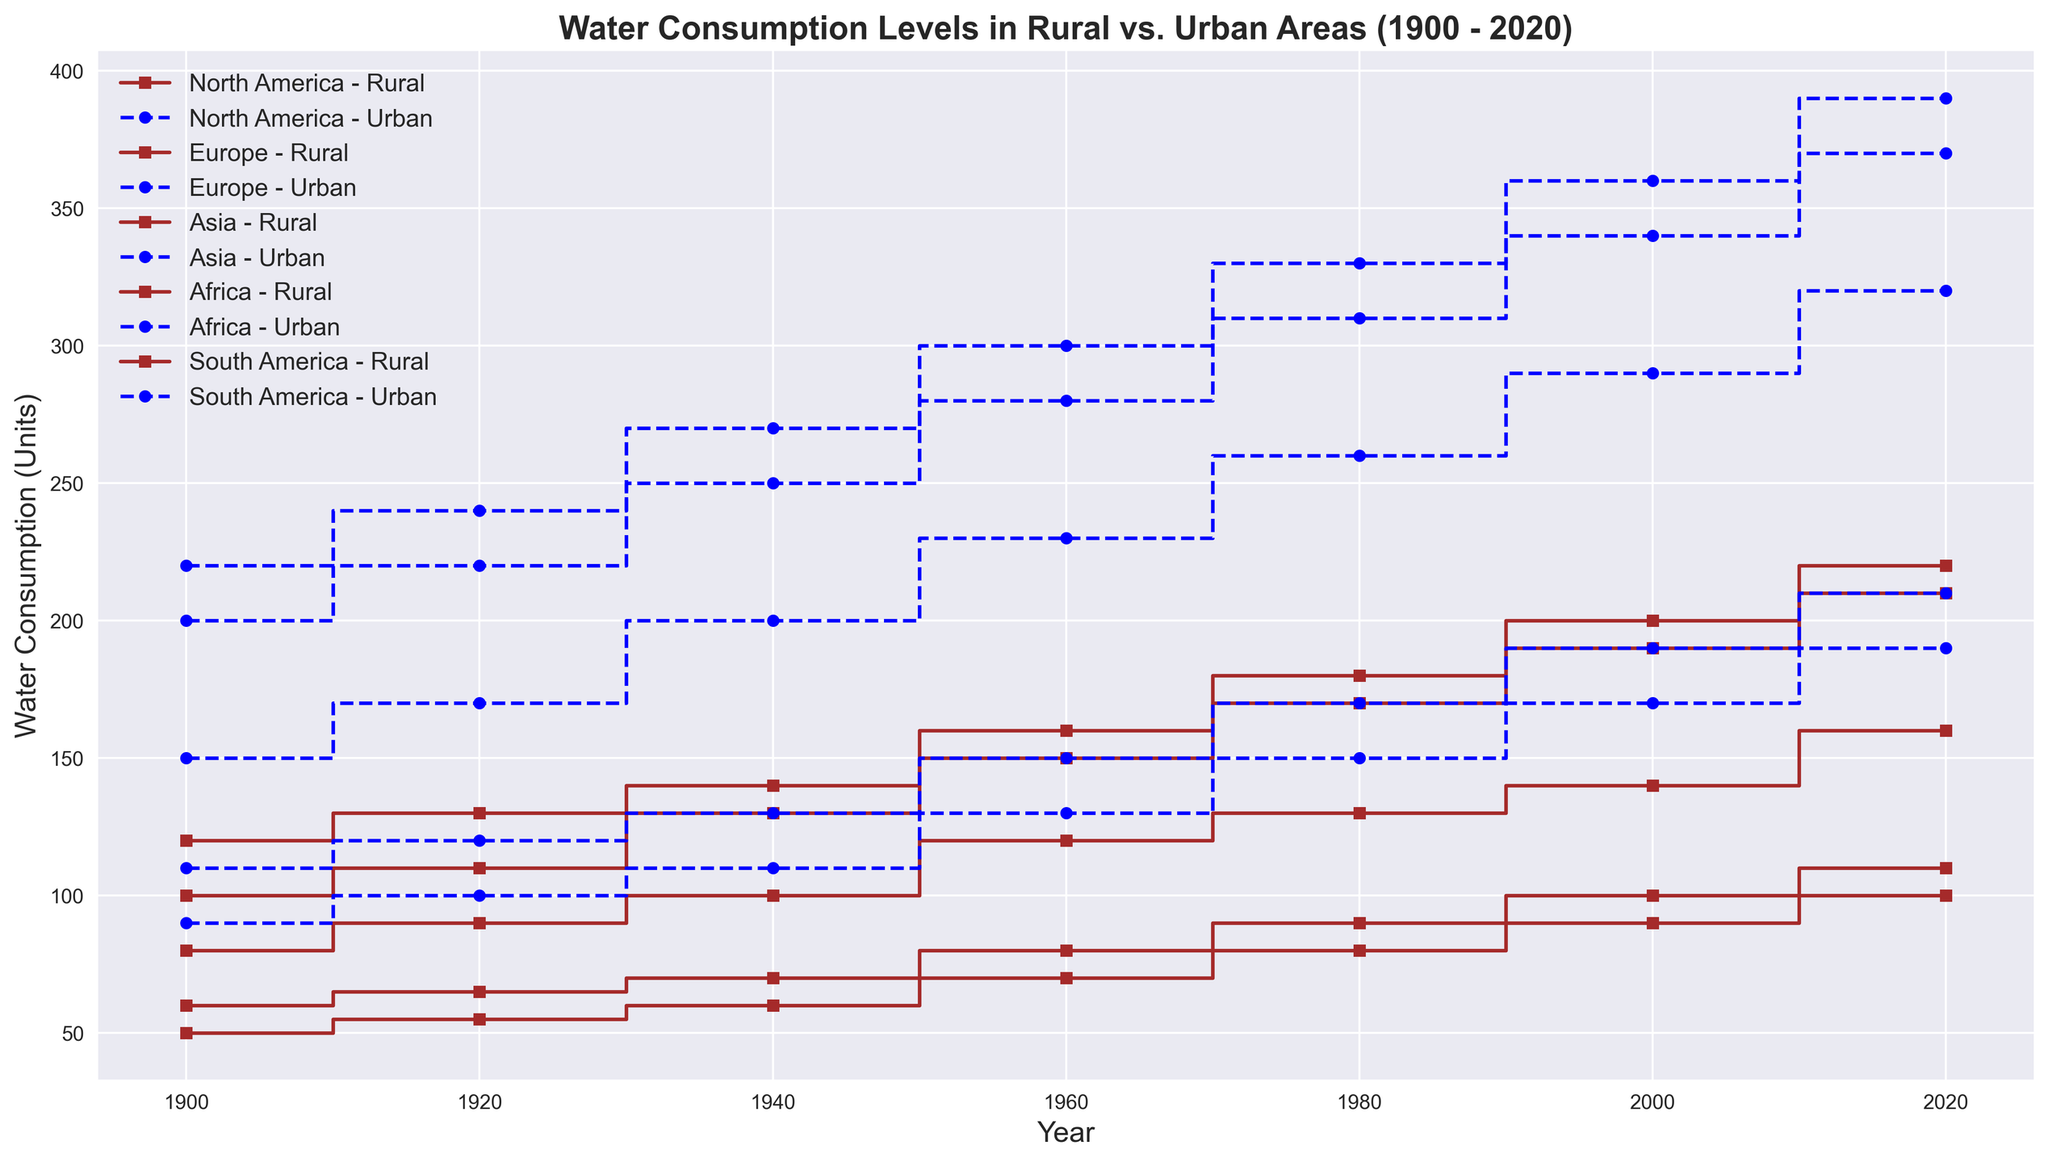Is the water consumption in Asia higher in urban or rural areas in 2020? Compare the values of water consumption in Asia for urban and rural areas in 2020. Urban areas have a consumption of 390 units, whereas rural areas have 220 units, so urban areas have higher consumption.
Answer: Urban In which region did rural water consumption increase the most between 1900 and 2020? Calculate the difference in rural water consumption between 1900 and 2020 for each region. North America: 210 - 100 = 110, Europe: 160 - 80 = 80, Asia: 220 - 120 = 100, Africa: 100 - 50 = 50, South America: 110 - 60 = 50. North America has the highest increase.
Answer: North America Which region had the highest urban water consumption in 1960? Compare the urban water consumption values for each region in 1960. The values are North America: 280, Europe: 230, Asia: 300, Africa: 130, South America: 150. Asia has the highest urban consumption.
Answer: Asia How did rural water consumption in Africa change from 1940 to 2020? Look at the values for rural water consumption in Africa in 1940 and 2020. In 1940, it was 60, and in 2020, it is 100. This indicates an increase.
Answer: Increased What is the total water consumption for both rural and urban areas in Europe in 2000? Add the water consumption values for rural and urban areas in Europe in 2000. Rural: 140, Urban: 290. Total = 140 + 290 = 430.
Answer: 430 Compare the difference in urban water consumption between 1960 and 2020 for South America. Subtract the 1960 value for urban water consumption in South America from the 2020 value. 2020: 210, 1960: 150, Difference = 210 - 150 = 60.
Answer: 60 What visual attribute differentiates rural and urban data points? Observe the color and marker style used for rural and urban areas. Rural data points are represented in brown with square markers, and urban data points are represented in blue with circle markers.
Answer: Color and marker style Which region showed the smallest change in rural water consumption from 1980 to 2020? Calculate the difference in rural water consumption for each region between 1980 and 2020. North America: 210 - 170 = 40, Europe: 160 - 130 = 30, Asia: 220 - 180 = 40, Africa: 100 - 80 = 20, South America: 110 - 90 = 20. Both Africa and South America show the smallest change with a difference of 20.
Answer: Africa and South America What was the urban water consumption in North America in 1940? Read the value directly from the urban water consumption dataset for North America in 1940, which is 250.
Answer: 250 How much did rural water consumption in Europe increase from 1960 to 2000? Subtract the 1960 value for rural water consumption in Europe from the 2000 value. 2000: 140, 1960: 120, Increase = 140 - 120 = 20.
Answer: 20 